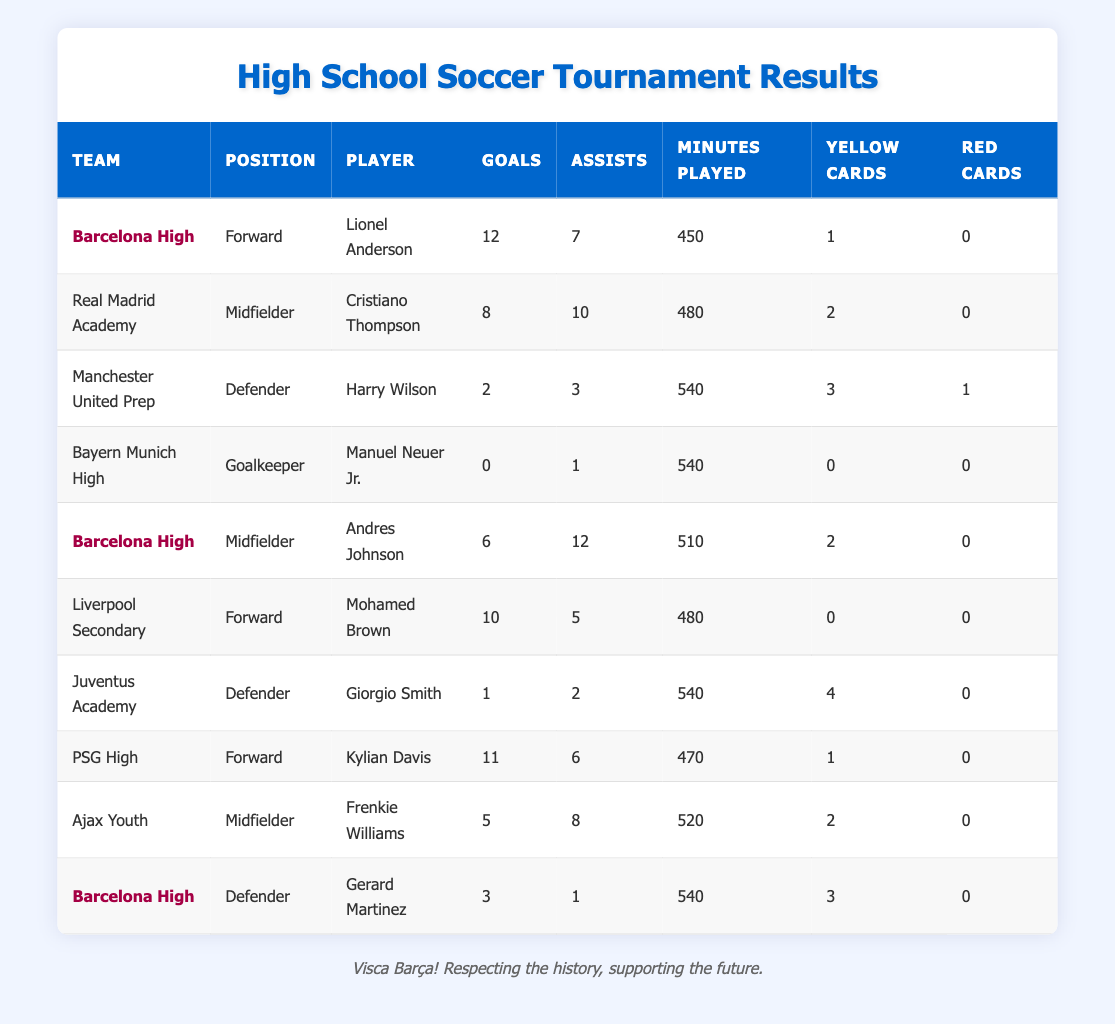What is the total number of goals scored by players from Barcelona High? The total goals scored by Barcelona High players can be found by adding the goals from all players in that team: Lionel Anderson (12) + Andres Johnson (6) + Gerard Martinez (3) = 21.
Answer: 21 Which player from PSG High has the highest number of goals? From PSG High, the only player listed is Kylian Davis, who scored 11 goals. Since no other players from PSG High are shown, he has the highest by default.
Answer: Kylian Davis What is the average number of assists for the players listed in the table? To find the average assists, we first sum the assists: 7 (Anderson) + 10 (Thompson) + 3 (Wilson) + 1 (Neuer Jr.) + 12 (Johnson) + 5 (Brown) + 2 (Smith) + 6 (Davis) + 8 (Williams) + 1 (Martinez) = 55. There are 10 players, so the average is 55/10 = 5.5.
Answer: 5.5 Did any player receive a red card during the tournament? We check through the table to see if any player has a red card listed. From the data, only Harry Wilson has 1 red card. The answer to whether any player received a red card is yes.
Answer: Yes Who had the most minutes played among midfielders? We look at the midfielders listed: Cristiano Thompson (480 minutes), Andres Johnson (510 minutes), and Frenkie Williams (520 minutes). The maximum minutes played is by Frenkie Williams, who played 520 minutes.
Answer: Frenkie Williams What was the total number of yellow cards given to players from Liverpool Secondary? The only player listed from Liverpool Secondary is Mohamed Brown, who received 0 yellow cards. Therefore, the total for Liverpool Secondary is simply 0.
Answer: 0 Which team has the highest total number of goals scored by its players? We sum the goals for each team: 
- Barcelona High: 12 + 6 + 3 = 21 
- Real Madrid Academy: 8 
- Manchester United Prep: 2 
- Bayern Munich High: 0 
- Liverpool Secondary: 10 
- Juventus Academy: 1 
- PSG High: 11 
- Ajax Youth: 5. The team with the highest total is Barcelona High with 21 goals.
Answer: Barcelona High Is there any defender who scored more than 1 goal? The defenders listed are Harry Wilson (2 goals), Giorgio Smith (1 goal), and Gerard Martinez (3 goals). Since Harry Wilson and Gerard Martinez both scored more than 1 goal, the answer is yes.
Answer: Yes What is the difference between the total assists of Barcelona High and PSG High? Summing the assists for Barcelona High (7 + 12 + 1 = 20) and for PSG High (6), the difference is 20 - 6 = 14.
Answer: 14 